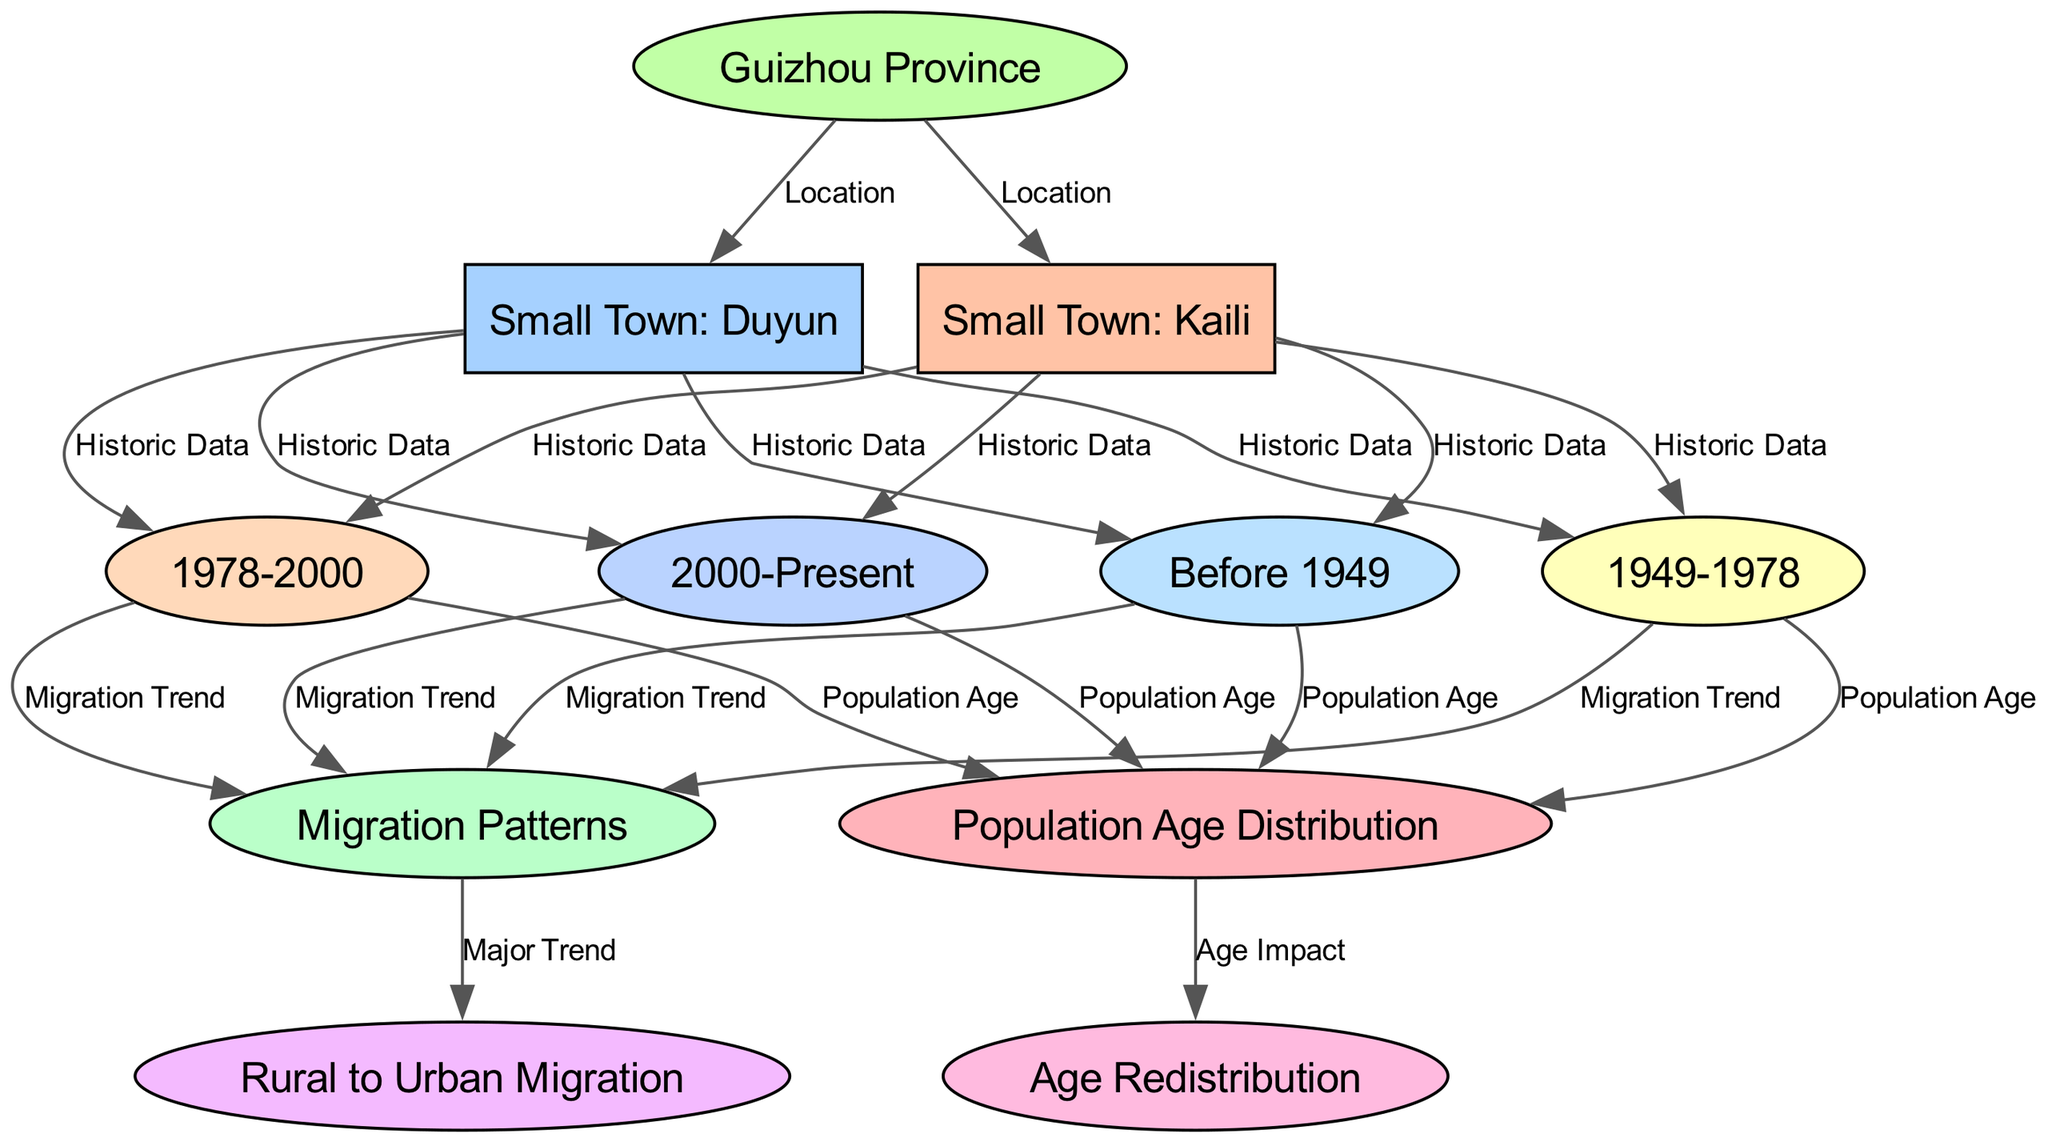what are the two main nodes representing demographic aspects in the diagram? The diagram clearly shows "Population Age Distribution" and "Migration Patterns" as the two main nodes, since they are labeled as key areas of focus regarding demographic changes.
Answer: Population Age Distribution, Migration Patterns how many historical periods are represented in the diagram? By counting the nodes specifically for historical periods (pre_1949, post_1949, post_1978, post_2000), we find that there are four distinct periods presented in the diagram.
Answer: 4 what is the major trend shown in the migration patterns? The migration patterns node indicates a significant trend of "Rural to Urban Migration," suggesting that many people are moving from rural areas to urban centers over time.
Answer: Rural to Urban Migration which town is connected to the historic period post_1978? The connections to "post_1978" show that both "Small Town: Kaili" and "Small Town: Duyun" are notable for historical data related to that period, indicating that both towns are analyzed for demographics after 1978.
Answer: Small Town: Kaili, Small Town: Duyun how does "Population Age Distribution" affect "Age Redistribution"? The connection labeled "Age Impact" indicates that there is a direct relationship where changes in the "Population Age Distribution" influence "Age Redistribution," showing how age demographics shift can lead to redistribution in age groups.
Answer: Age Impact what is one of the two small towns located in Guizhou Province? Based on the diagram, "Small Town: Kaili" is one of the two towns directly connected to "Guizhou Province," which signifies its geographical pertinence to the data being presented.
Answer: Small Town: Kaili what label connects the post_2000 period to migration patterns? The edge that links "post_2000" with "migration_patterns" is labeled "Migration Trend," indicating that the trends in migration continue to be examined even in this most recent period.
Answer: Migration Trend 